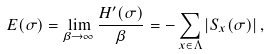Convert formula to latex. <formula><loc_0><loc_0><loc_500><loc_500>E ( \sigma ) = \lim _ { \beta \to \infty } \frac { H ^ { \prime } ( \sigma ) } { \beta } = - \sum _ { x \in \Lambda } | S _ { x } ( \sigma ) | \, ,</formula> 